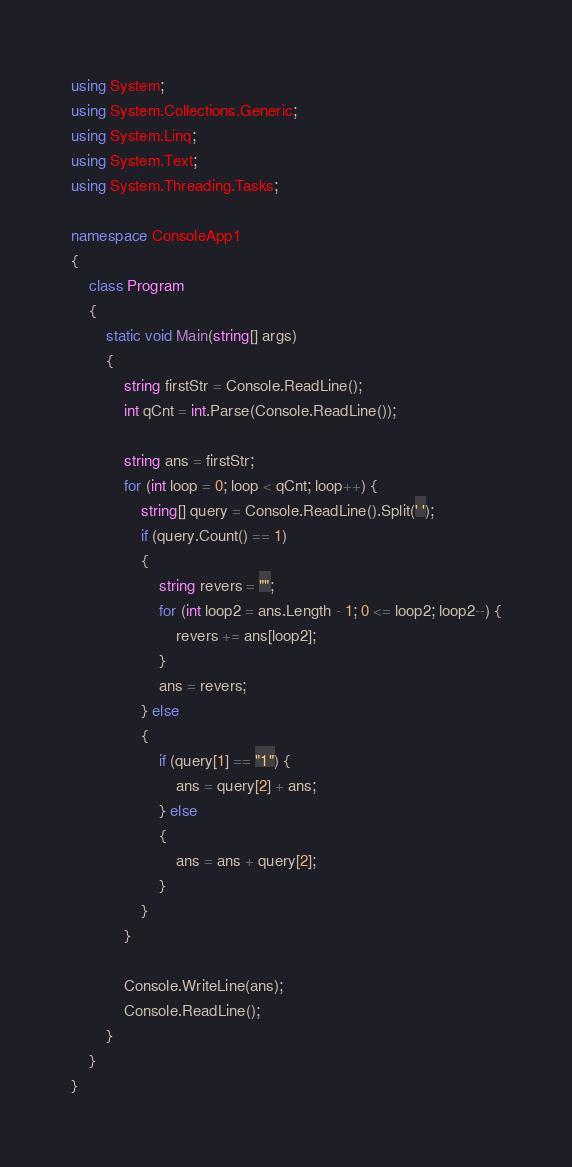<code> <loc_0><loc_0><loc_500><loc_500><_C#_>using System;
using System.Collections.Generic;
using System.Linq;
using System.Text;
using System.Threading.Tasks;

namespace ConsoleApp1
{
    class Program
    {
        static void Main(string[] args)
        {
            string firstStr = Console.ReadLine();
            int qCnt = int.Parse(Console.ReadLine());

            string ans = firstStr;
            for (int loop = 0; loop < qCnt; loop++) {
                string[] query = Console.ReadLine().Split(' ');
                if (query.Count() == 1)
                {
                    string revers = "";
                    for (int loop2 = ans.Length - 1; 0 <= loop2; loop2--) {
                        revers += ans[loop2];
                    }
                    ans = revers;
                } else
                {
                    if (query[1] == "1") {
                        ans = query[2] + ans;
                    } else
                    {
                        ans = ans + query[2];
                    }
                }
            }

            Console.WriteLine(ans);
            Console.ReadLine();
        }
    }
}
</code> 